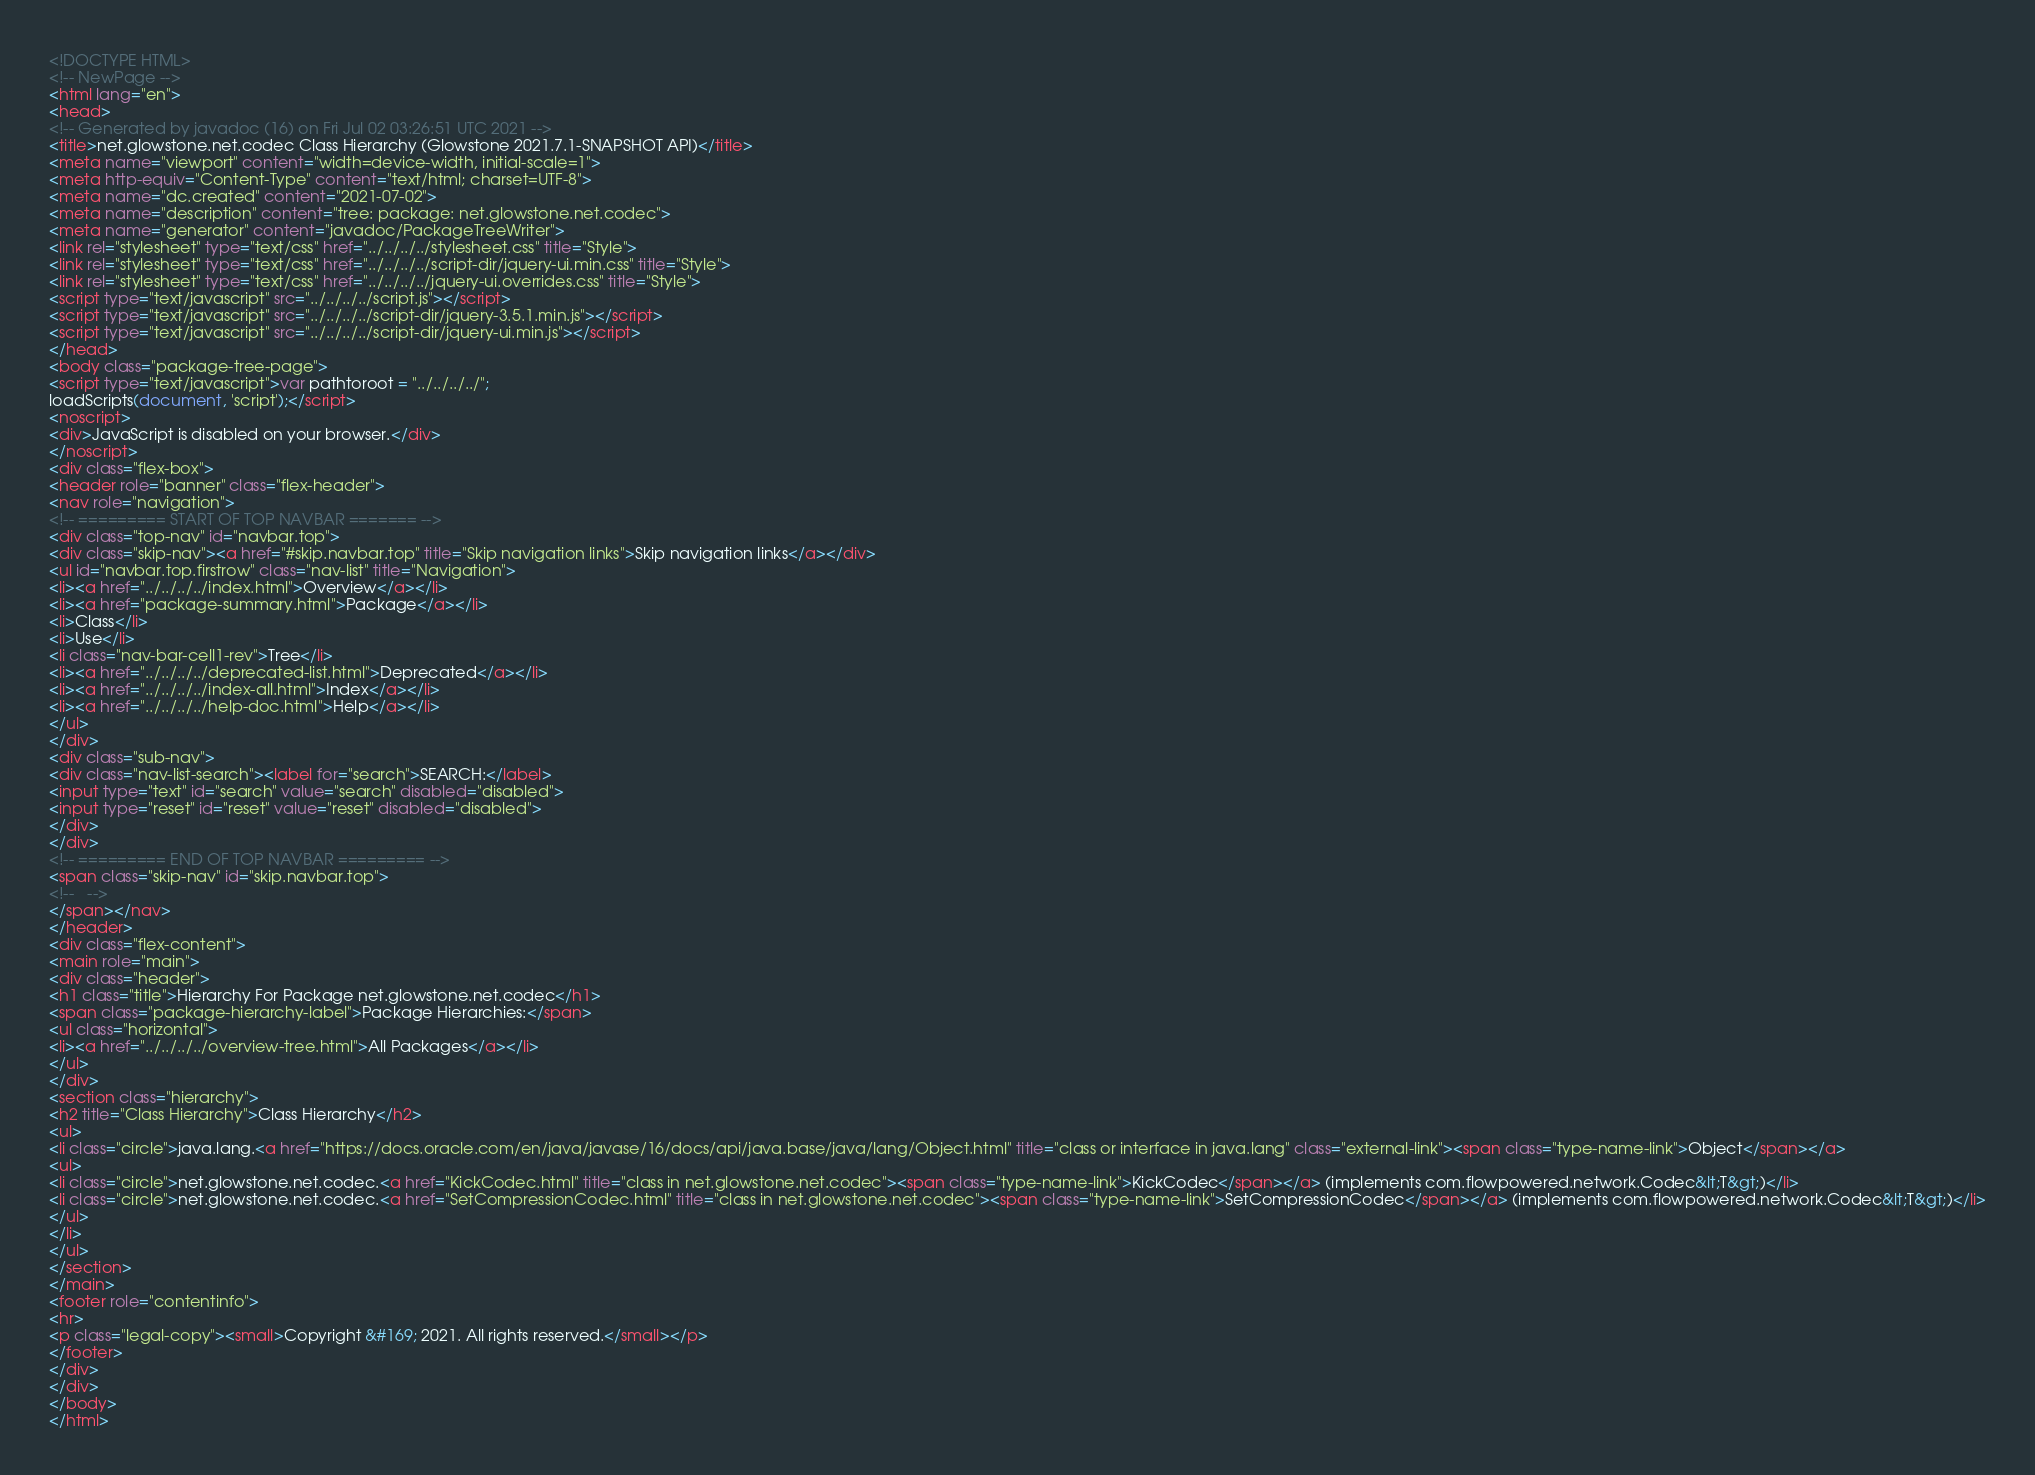Convert code to text. <code><loc_0><loc_0><loc_500><loc_500><_HTML_><!DOCTYPE HTML>
<!-- NewPage -->
<html lang="en">
<head>
<!-- Generated by javadoc (16) on Fri Jul 02 03:26:51 UTC 2021 -->
<title>net.glowstone.net.codec Class Hierarchy (Glowstone 2021.7.1-SNAPSHOT API)</title>
<meta name="viewport" content="width=device-width, initial-scale=1">
<meta http-equiv="Content-Type" content="text/html; charset=UTF-8">
<meta name="dc.created" content="2021-07-02">
<meta name="description" content="tree: package: net.glowstone.net.codec">
<meta name="generator" content="javadoc/PackageTreeWriter">
<link rel="stylesheet" type="text/css" href="../../../../stylesheet.css" title="Style">
<link rel="stylesheet" type="text/css" href="../../../../script-dir/jquery-ui.min.css" title="Style">
<link rel="stylesheet" type="text/css" href="../../../../jquery-ui.overrides.css" title="Style">
<script type="text/javascript" src="../../../../script.js"></script>
<script type="text/javascript" src="../../../../script-dir/jquery-3.5.1.min.js"></script>
<script type="text/javascript" src="../../../../script-dir/jquery-ui.min.js"></script>
</head>
<body class="package-tree-page">
<script type="text/javascript">var pathtoroot = "../../../../";
loadScripts(document, 'script');</script>
<noscript>
<div>JavaScript is disabled on your browser.</div>
</noscript>
<div class="flex-box">
<header role="banner" class="flex-header">
<nav role="navigation">
<!-- ========= START OF TOP NAVBAR ======= -->
<div class="top-nav" id="navbar.top">
<div class="skip-nav"><a href="#skip.navbar.top" title="Skip navigation links">Skip navigation links</a></div>
<ul id="navbar.top.firstrow" class="nav-list" title="Navigation">
<li><a href="../../../../index.html">Overview</a></li>
<li><a href="package-summary.html">Package</a></li>
<li>Class</li>
<li>Use</li>
<li class="nav-bar-cell1-rev">Tree</li>
<li><a href="../../../../deprecated-list.html">Deprecated</a></li>
<li><a href="../../../../index-all.html">Index</a></li>
<li><a href="../../../../help-doc.html">Help</a></li>
</ul>
</div>
<div class="sub-nav">
<div class="nav-list-search"><label for="search">SEARCH:</label>
<input type="text" id="search" value="search" disabled="disabled">
<input type="reset" id="reset" value="reset" disabled="disabled">
</div>
</div>
<!-- ========= END OF TOP NAVBAR ========= -->
<span class="skip-nav" id="skip.navbar.top">
<!--   -->
</span></nav>
</header>
<div class="flex-content">
<main role="main">
<div class="header">
<h1 class="title">Hierarchy For Package net.glowstone.net.codec</h1>
<span class="package-hierarchy-label">Package Hierarchies:</span>
<ul class="horizontal">
<li><a href="../../../../overview-tree.html">All Packages</a></li>
</ul>
</div>
<section class="hierarchy">
<h2 title="Class Hierarchy">Class Hierarchy</h2>
<ul>
<li class="circle">java.lang.<a href="https://docs.oracle.com/en/java/javase/16/docs/api/java.base/java/lang/Object.html" title="class or interface in java.lang" class="external-link"><span class="type-name-link">Object</span></a>
<ul>
<li class="circle">net.glowstone.net.codec.<a href="KickCodec.html" title="class in net.glowstone.net.codec"><span class="type-name-link">KickCodec</span></a> (implements com.flowpowered.network.Codec&lt;T&gt;)</li>
<li class="circle">net.glowstone.net.codec.<a href="SetCompressionCodec.html" title="class in net.glowstone.net.codec"><span class="type-name-link">SetCompressionCodec</span></a> (implements com.flowpowered.network.Codec&lt;T&gt;)</li>
</ul>
</li>
</ul>
</section>
</main>
<footer role="contentinfo">
<hr>
<p class="legal-copy"><small>Copyright &#169; 2021. All rights reserved.</small></p>
</footer>
</div>
</div>
</body>
</html>
</code> 